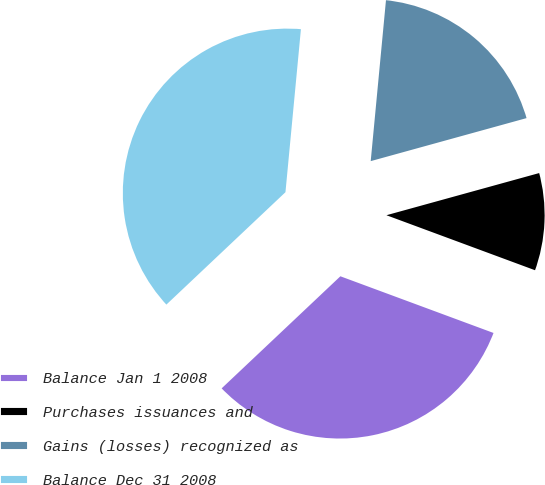<chart> <loc_0><loc_0><loc_500><loc_500><pie_chart><fcel>Balance Jan 1 2008<fcel>Purchases issuances and<fcel>Gains (losses) recognized as<fcel>Balance Dec 31 2008<nl><fcel>32.32%<fcel>9.93%<fcel>19.21%<fcel>38.55%<nl></chart> 